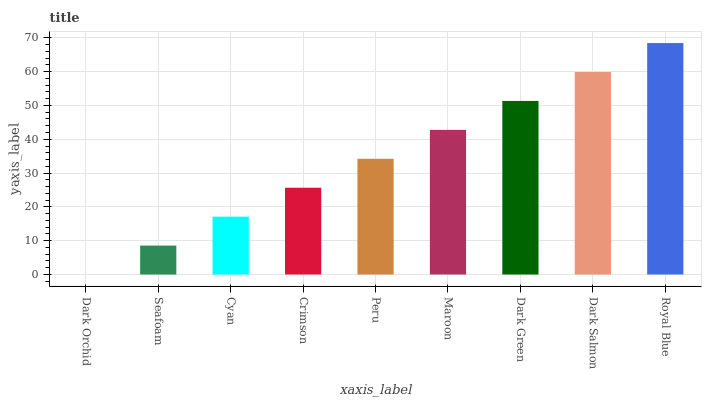Is Dark Orchid the minimum?
Answer yes or no. Yes. Is Royal Blue the maximum?
Answer yes or no. Yes. Is Seafoam the minimum?
Answer yes or no. No. Is Seafoam the maximum?
Answer yes or no. No. Is Seafoam greater than Dark Orchid?
Answer yes or no. Yes. Is Dark Orchid less than Seafoam?
Answer yes or no. Yes. Is Dark Orchid greater than Seafoam?
Answer yes or no. No. Is Seafoam less than Dark Orchid?
Answer yes or no. No. Is Peru the high median?
Answer yes or no. Yes. Is Peru the low median?
Answer yes or no. Yes. Is Seafoam the high median?
Answer yes or no. No. Is Maroon the low median?
Answer yes or no. No. 